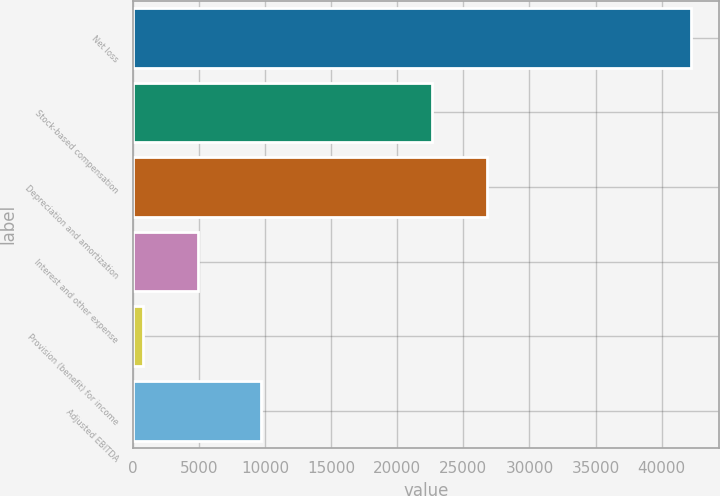<chart> <loc_0><loc_0><loc_500><loc_500><bar_chart><fcel>Net loss<fcel>Stock-based compensation<fcel>Depreciation and amortization<fcel>Interest and other expense<fcel>Provision (benefit) for income<fcel>Adjusted EBITDA<nl><fcel>42225<fcel>22646<fcel>26790.8<fcel>4921.8<fcel>777<fcel>9647<nl></chart> 